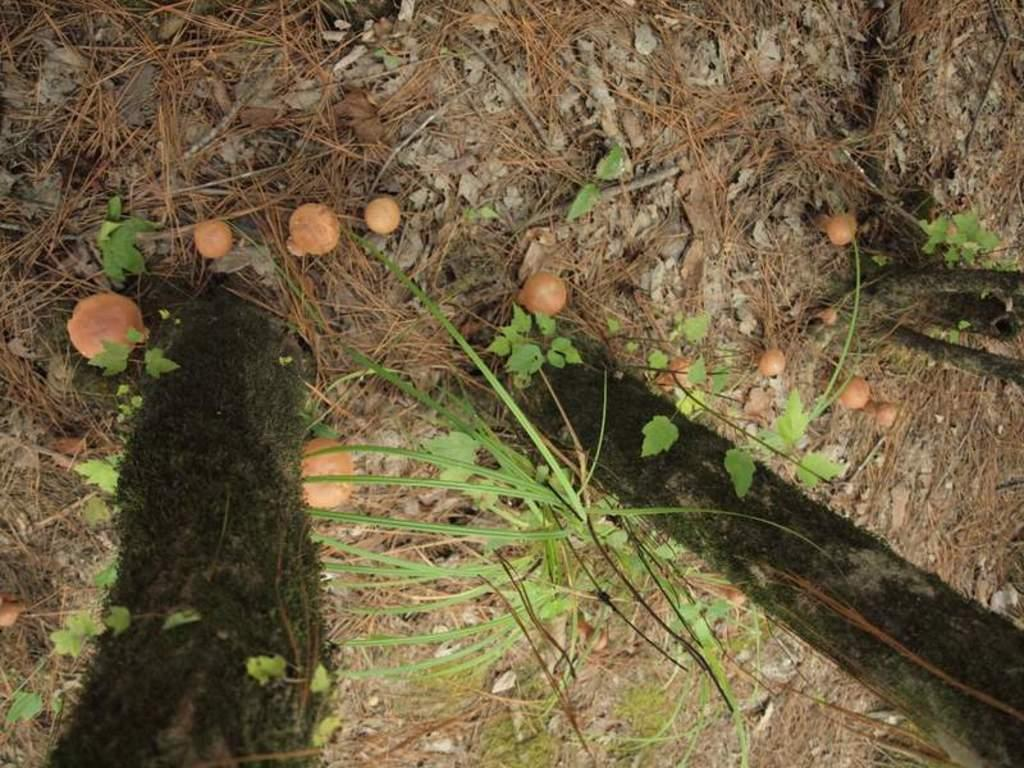What type of fungi can be seen on the ground in the image? There are mushrooms on the ground in the image. What color are the mushrooms? The mushrooms are in cream color. What type of vegetation is visible in the image? There are trees and plants visible in the image. What type of voice can be heard coming from the mushrooms in the image? There is no voice coming from the mushrooms in the image, as they are inanimate objects and do not have the ability to produce sound. 